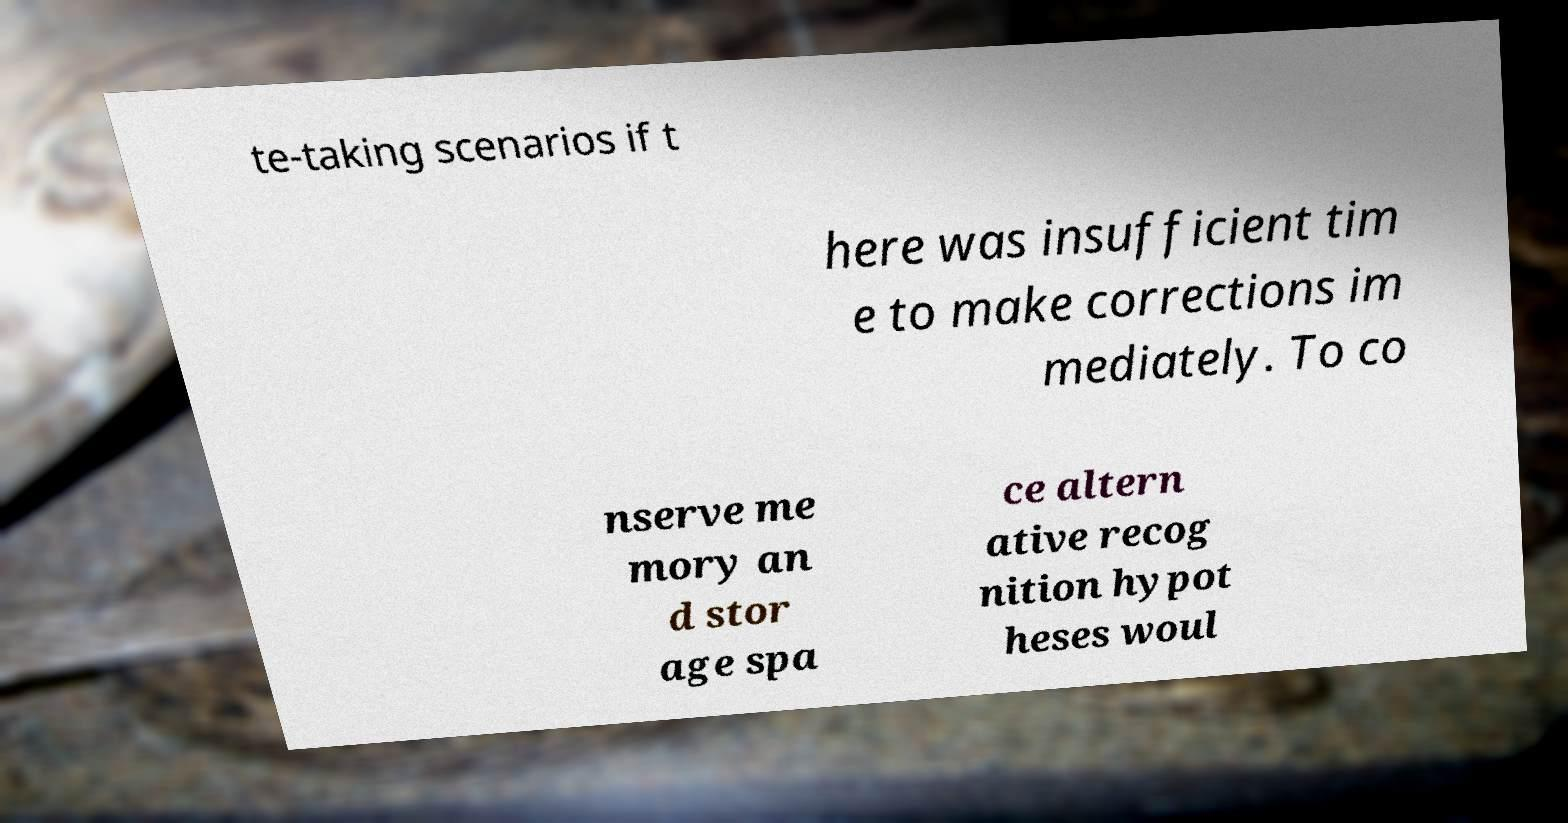For documentation purposes, I need the text within this image transcribed. Could you provide that? te-taking scenarios if t here was insufficient tim e to make corrections im mediately. To co nserve me mory an d stor age spa ce altern ative recog nition hypot heses woul 